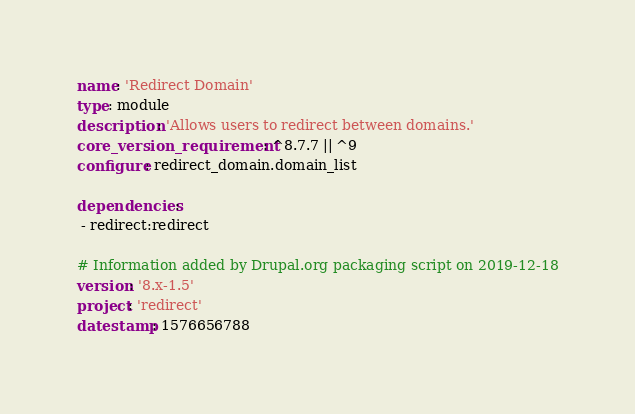<code> <loc_0><loc_0><loc_500><loc_500><_YAML_>name: 'Redirect Domain'
type: module
description: 'Allows users to redirect between domains.'
core_version_requirement: ^8.7.7 || ^9
configure: redirect_domain.domain_list

dependencies:
 - redirect:redirect

# Information added by Drupal.org packaging script on 2019-12-18
version: '8.x-1.5'
project: 'redirect'
datestamp: 1576656788
</code> 